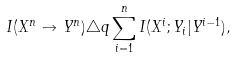<formula> <loc_0><loc_0><loc_500><loc_500>I ( X ^ { n } \to Y ^ { n } ) \triangle q \sum _ { i = 1 } ^ { n } I ( X ^ { i } ; Y _ { i } | Y ^ { i - 1 } ) ,</formula> 